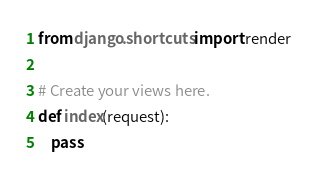Convert code to text. <code><loc_0><loc_0><loc_500><loc_500><_Python_>from django.shortcuts import render

# Create your views here.
def index(request):
    pass</code> 